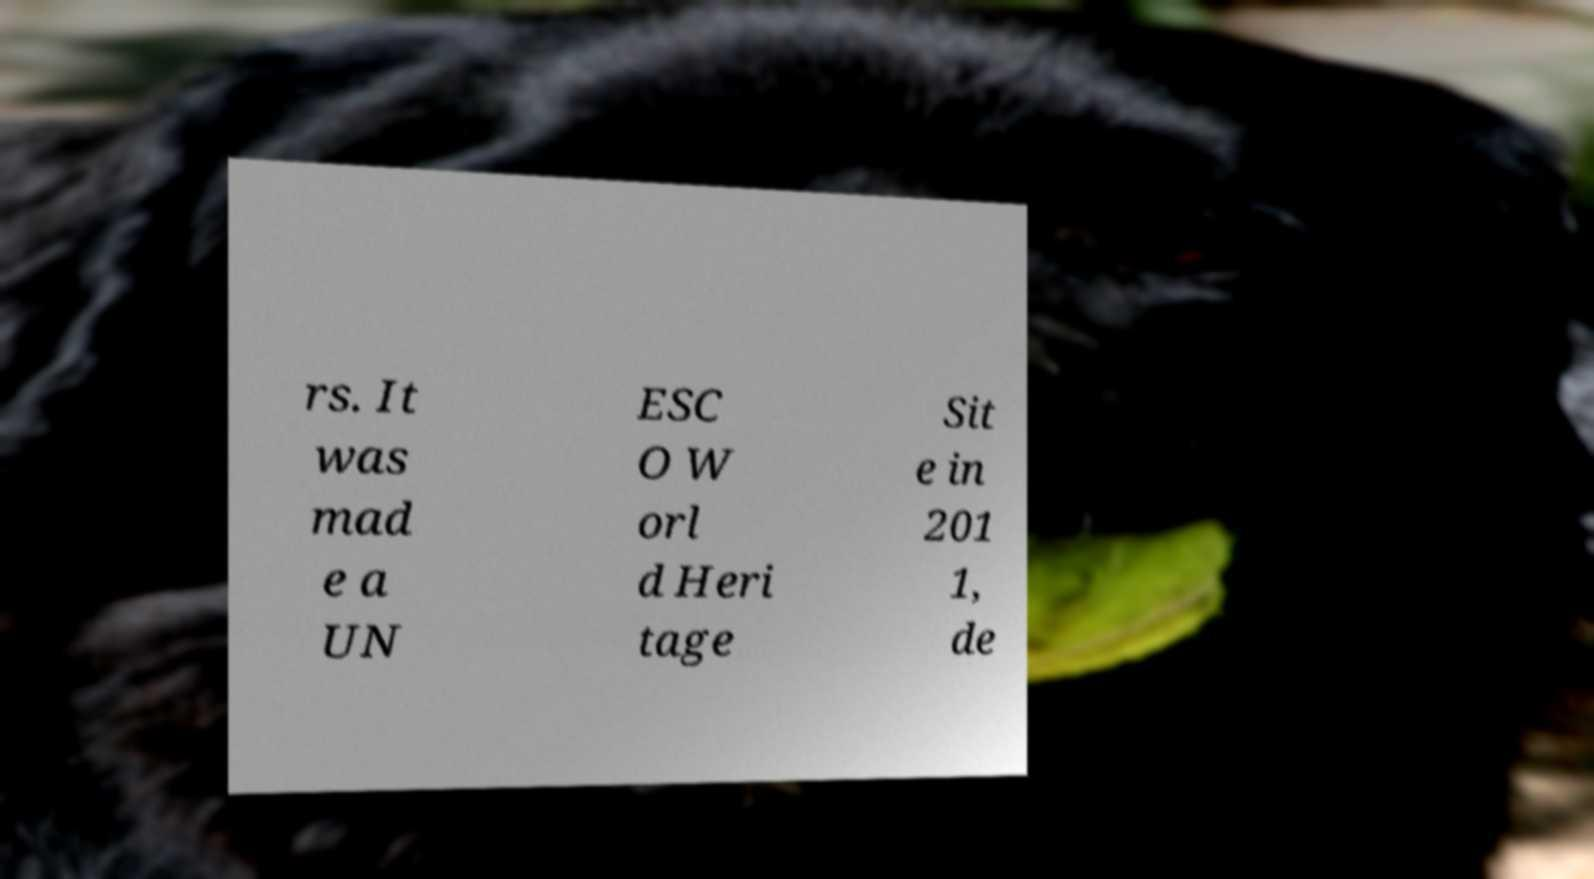Could you extract and type out the text from this image? rs. It was mad e a UN ESC O W orl d Heri tage Sit e in 201 1, de 